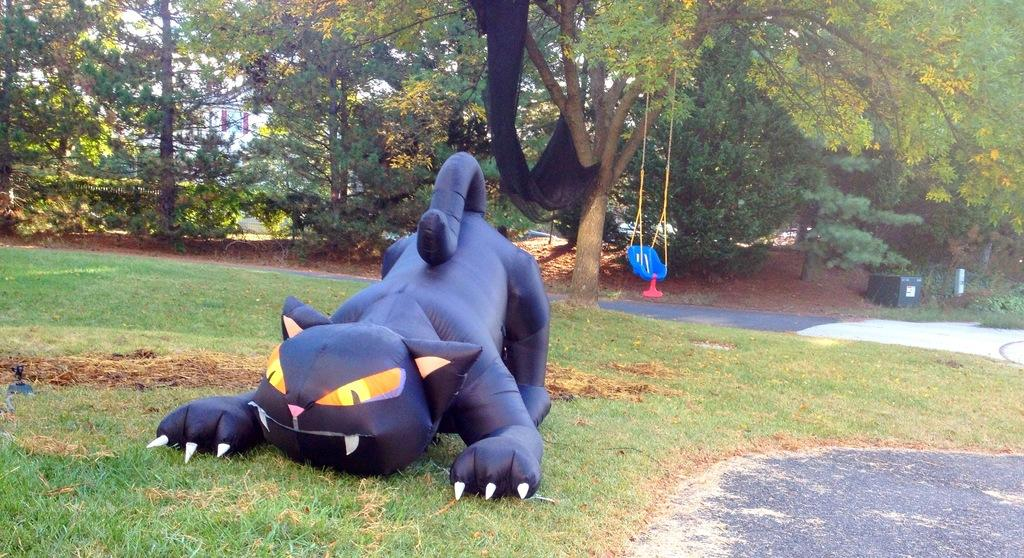What is the main subject in the center of the image? There is an air balloon in the center of the image. Where is the air balloon located? The air balloon is on the grass. What can be seen in the background of the image? There is a swing, trees, and a building in the background of the image. What type of magic is being performed with the produce in the image? There is no magic or produce present in the image; it features an air balloon on the grass with a background containing a swing, trees, and a building. 